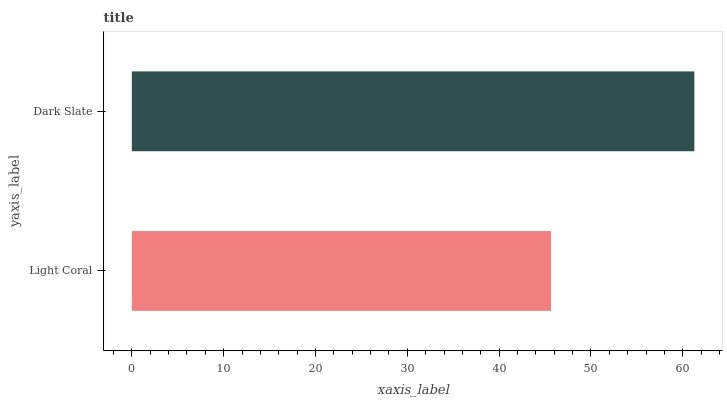Is Light Coral the minimum?
Answer yes or no. Yes. Is Dark Slate the maximum?
Answer yes or no. Yes. Is Dark Slate the minimum?
Answer yes or no. No. Is Dark Slate greater than Light Coral?
Answer yes or no. Yes. Is Light Coral less than Dark Slate?
Answer yes or no. Yes. Is Light Coral greater than Dark Slate?
Answer yes or no. No. Is Dark Slate less than Light Coral?
Answer yes or no. No. Is Dark Slate the high median?
Answer yes or no. Yes. Is Light Coral the low median?
Answer yes or no. Yes. Is Light Coral the high median?
Answer yes or no. No. Is Dark Slate the low median?
Answer yes or no. No. 